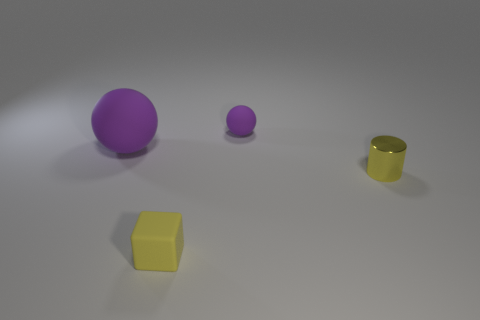Comparing the yellow objects, can you describe any differences in shade or luminance between them? While both yellow objects have the same color, the yellow cube seems slightly brighter, possibly due to its matte surface reflecting more ambient light compared to the shiny surface of the cylinder. 